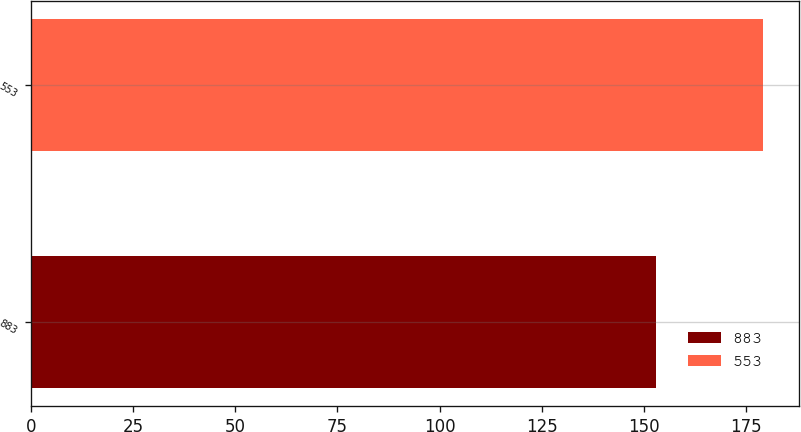<chart> <loc_0><loc_0><loc_500><loc_500><bar_chart><fcel>883<fcel>553<nl><fcel>153<fcel>179<nl></chart> 